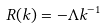Convert formula to latex. <formula><loc_0><loc_0><loc_500><loc_500>R ( k ) = - { \Lambda } k ^ { - 1 }</formula> 